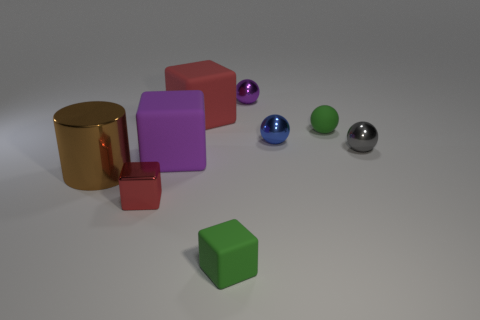Subtract all gray cubes. Subtract all red balls. How many cubes are left? 4 Add 1 large objects. How many objects exist? 10 Subtract all blocks. How many objects are left? 5 Add 3 small things. How many small things are left? 9 Add 4 large purple matte objects. How many large purple matte objects exist? 5 Subtract 1 green blocks. How many objects are left? 8 Subtract all small gray balls. Subtract all tiny metal cubes. How many objects are left? 7 